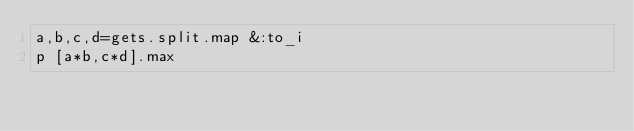<code> <loc_0><loc_0><loc_500><loc_500><_Ruby_>a,b,c,d=gets.split.map &:to_i
p [a*b,c*d].max</code> 